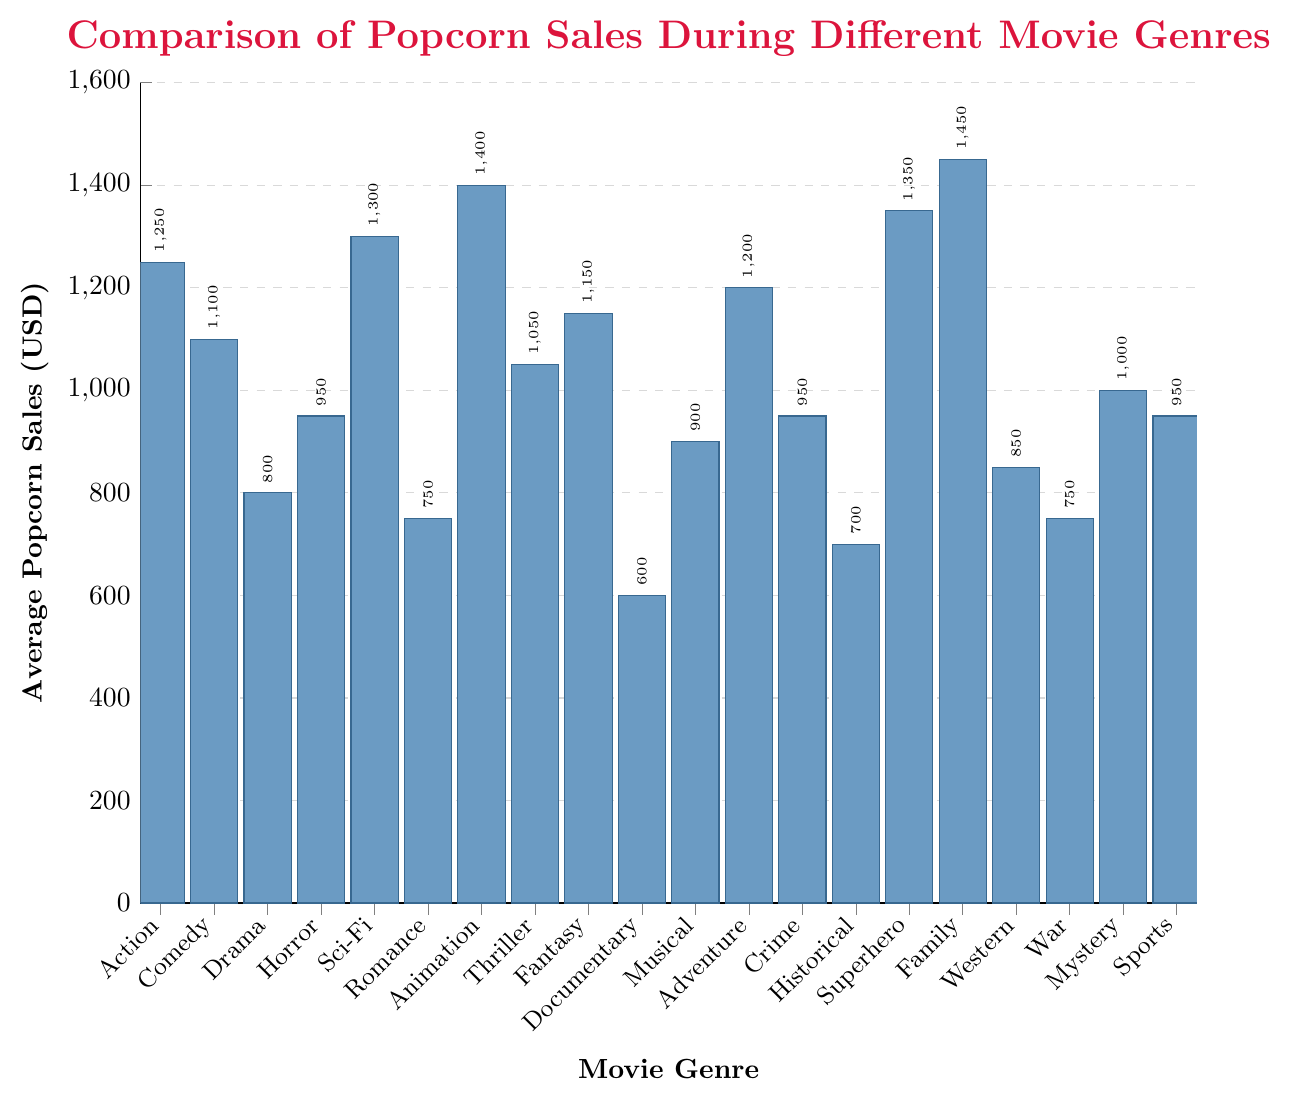Which movie genre has the highest average popcorn sales? Look for the highest bar in the chart. The highest bar corresponds to the Family genre, at 1450 USD.
Answer: Family Which movie genre has the lowest average popcorn sales? Look for the shortest bar in the chart. The shortest bar corresponds to the Documentary genre, at 600 USD.
Answer: Documentary What is the difference in average popcorn sales between the highest and lowest selling genres? Subtract the average sales of the lowest selling genre (Documentary, 600 USD) from the highest selling genre (Family, 1450 USD): 1450 - 600
Answer: 850 How do the average popcorn sales of Superhero and Animation genres compare? Compare the height of the bars for Superhero and Animation genres. The Superhero genre has average sales of 1350 USD, and Animation has 1400 USD, so Animation is higher.
Answer: Animation > Superhero What is the total average popcorn sales for Action, Comedy, and Adventure genres combined? Sum the average sales of Action (1250 USD), Comedy (1100 USD), and Adventure (1200 USD): 1250 + 1100 + 1200
Answer: 3550 Which genre has higher average popcorn sales: Thriller or Mystery? Compare the height of the bars: Thriller has average sales of 1050 USD, while Mystery has 1000 USD, so Thriller is higher.
Answer: Thriller Between Horror and Crime genres, which one has lower average popcorn sales, and by how much? Compare the bars for Horror (950 USD) and Crime (950 USD). They are equal, so there is no difference.
Answer: Horror = Crime How many genres have an average popcorn sales value greater than 1200 USD? Count the number of genres with bars taller than 1200: Sci-Fi (1300 USD), Animation (1400 USD), Superhero (1350 USD), Family (1450 USD).
Answer: 4 What is the average popcorn sales value of the genres lower than the median value? The median value is found by listing sales values in order. The median value here is 950 USD. Lower genres: Documentary (600), Historical (700), Romance (750), War (750), Western (850), Drama (800), Musical (900). Average these values: (600+700+750+750+850+800+900)/7 = 6210/7
Answer: 887.14 How does the average popcorn sales of Fantasy compare to that of Comedy? Compare the height of the bars for Fantasy (1150 USD) and Comedy (1100 USD).
Answer: Fantasy > Comedy 